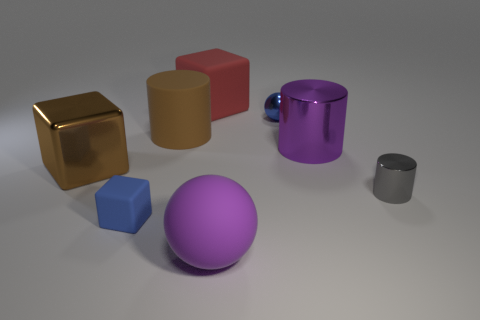How do the objects compare in size relative to each other? The golden cube is the largest object, followed by the red rectangular cuboid. The purple sphere is medium-sized, the blue cube is smaller, and the small gray cylinder is the smallest. The purple cylinder stands out due to its vibrant color and it's larger than the gray cylinder but smaller in comparison to the cubes.  What can you infer about the sizes based on their interaction with the light? The larger objects cast broader shadows that are more diffused, while the smaller objects produce sharper, more defined shadows. This indicates that the smaller objects are closer to the surface they rest on. 